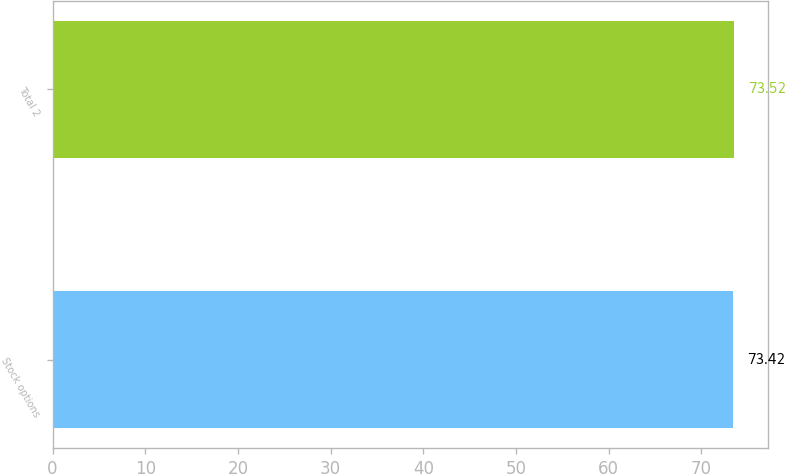Convert chart to OTSL. <chart><loc_0><loc_0><loc_500><loc_500><bar_chart><fcel>Stock options<fcel>Total 2<nl><fcel>73.42<fcel>73.52<nl></chart> 